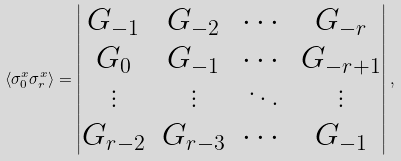Convert formula to latex. <formula><loc_0><loc_0><loc_500><loc_500>\langle \sigma _ { 0 } ^ { x } \sigma _ { r } ^ { x } \rangle = \begin{vmatrix} G _ { - 1 } & G _ { - 2 } & \cdots & G _ { - r } \\ G _ { 0 } & G _ { - 1 } & \cdots & G _ { - r + 1 } \\ \vdots & \vdots & \ddots & \vdots \\ G _ { r - 2 } & G _ { r - 3 } & \cdots & G _ { - 1 } \end{vmatrix} ,</formula> 